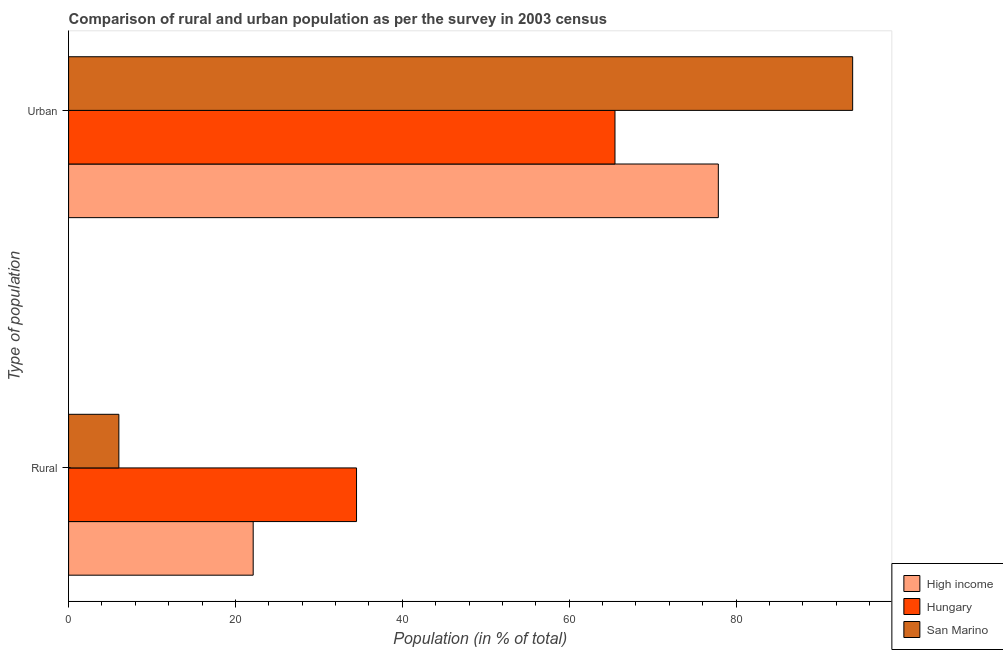How many groups of bars are there?
Keep it short and to the point. 2. Are the number of bars per tick equal to the number of legend labels?
Your response must be concise. Yes. Are the number of bars on each tick of the Y-axis equal?
Your answer should be very brief. Yes. What is the label of the 2nd group of bars from the top?
Keep it short and to the point. Rural. What is the urban population in San Marino?
Provide a short and direct response. 93.97. Across all countries, what is the maximum rural population?
Provide a short and direct response. 34.51. Across all countries, what is the minimum urban population?
Ensure brevity in your answer.  65.49. In which country was the rural population maximum?
Make the answer very short. Hungary. In which country was the urban population minimum?
Your answer should be very brief. Hungary. What is the total rural population in the graph?
Your answer should be compact. 62.66. What is the difference between the urban population in High income and that in San Marino?
Offer a terse response. -16.1. What is the difference between the rural population in Hungary and the urban population in San Marino?
Keep it short and to the point. -59.46. What is the average rural population per country?
Provide a short and direct response. 20.89. What is the difference between the rural population and urban population in High income?
Ensure brevity in your answer.  -55.75. In how many countries, is the rural population greater than 64 %?
Provide a short and direct response. 0. What is the ratio of the urban population in High income to that in San Marino?
Your response must be concise. 0.83. What does the 2nd bar from the top in Urban represents?
Ensure brevity in your answer.  Hungary. What does the 2nd bar from the bottom in Urban represents?
Offer a terse response. Hungary. How many countries are there in the graph?
Your answer should be very brief. 3. Does the graph contain any zero values?
Your response must be concise. No. How many legend labels are there?
Your response must be concise. 3. How are the legend labels stacked?
Keep it short and to the point. Vertical. What is the title of the graph?
Your response must be concise. Comparison of rural and urban population as per the survey in 2003 census. What is the label or title of the X-axis?
Ensure brevity in your answer.  Population (in % of total). What is the label or title of the Y-axis?
Your response must be concise. Type of population. What is the Population (in % of total) in High income in Rural?
Ensure brevity in your answer.  22.12. What is the Population (in % of total) of Hungary in Rural?
Keep it short and to the point. 34.51. What is the Population (in % of total) of San Marino in Rural?
Provide a short and direct response. 6.03. What is the Population (in % of total) of High income in Urban?
Your answer should be very brief. 77.88. What is the Population (in % of total) of Hungary in Urban?
Offer a terse response. 65.49. What is the Population (in % of total) in San Marino in Urban?
Provide a short and direct response. 93.97. Across all Type of population, what is the maximum Population (in % of total) of High income?
Ensure brevity in your answer.  77.88. Across all Type of population, what is the maximum Population (in % of total) of Hungary?
Give a very brief answer. 65.49. Across all Type of population, what is the maximum Population (in % of total) of San Marino?
Your answer should be compact. 93.97. Across all Type of population, what is the minimum Population (in % of total) of High income?
Offer a terse response. 22.12. Across all Type of population, what is the minimum Population (in % of total) in Hungary?
Offer a very short reply. 34.51. Across all Type of population, what is the minimum Population (in % of total) in San Marino?
Make the answer very short. 6.03. What is the total Population (in % of total) in High income in the graph?
Keep it short and to the point. 100. What is the total Population (in % of total) of Hungary in the graph?
Offer a terse response. 100. What is the total Population (in % of total) in San Marino in the graph?
Give a very brief answer. 100. What is the difference between the Population (in % of total) in High income in Rural and that in Urban?
Keep it short and to the point. -55.75. What is the difference between the Population (in % of total) in Hungary in Rural and that in Urban?
Offer a very short reply. -30.98. What is the difference between the Population (in % of total) of San Marino in Rural and that in Urban?
Make the answer very short. -87.95. What is the difference between the Population (in % of total) in High income in Rural and the Population (in % of total) in Hungary in Urban?
Your response must be concise. -43.36. What is the difference between the Population (in % of total) in High income in Rural and the Population (in % of total) in San Marino in Urban?
Your response must be concise. -71.85. What is the difference between the Population (in % of total) in Hungary in Rural and the Population (in % of total) in San Marino in Urban?
Provide a succinct answer. -59.46. What is the average Population (in % of total) of San Marino per Type of population?
Your answer should be very brief. 50. What is the difference between the Population (in % of total) of High income and Population (in % of total) of Hungary in Rural?
Ensure brevity in your answer.  -12.39. What is the difference between the Population (in % of total) in High income and Population (in % of total) in San Marino in Rural?
Give a very brief answer. 16.1. What is the difference between the Population (in % of total) of Hungary and Population (in % of total) of San Marino in Rural?
Offer a terse response. 28.49. What is the difference between the Population (in % of total) in High income and Population (in % of total) in Hungary in Urban?
Keep it short and to the point. 12.39. What is the difference between the Population (in % of total) in High income and Population (in % of total) in San Marino in Urban?
Offer a very short reply. -16.1. What is the difference between the Population (in % of total) in Hungary and Population (in % of total) in San Marino in Urban?
Keep it short and to the point. -28.49. What is the ratio of the Population (in % of total) of High income in Rural to that in Urban?
Make the answer very short. 0.28. What is the ratio of the Population (in % of total) in Hungary in Rural to that in Urban?
Your answer should be very brief. 0.53. What is the ratio of the Population (in % of total) in San Marino in Rural to that in Urban?
Make the answer very short. 0.06. What is the difference between the highest and the second highest Population (in % of total) of High income?
Your response must be concise. 55.75. What is the difference between the highest and the second highest Population (in % of total) of Hungary?
Your answer should be compact. 30.98. What is the difference between the highest and the second highest Population (in % of total) of San Marino?
Ensure brevity in your answer.  87.95. What is the difference between the highest and the lowest Population (in % of total) of High income?
Provide a succinct answer. 55.75. What is the difference between the highest and the lowest Population (in % of total) in Hungary?
Keep it short and to the point. 30.98. What is the difference between the highest and the lowest Population (in % of total) in San Marino?
Ensure brevity in your answer.  87.95. 